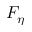Convert formula to latex. <formula><loc_0><loc_0><loc_500><loc_500>F _ { \eta }</formula> 